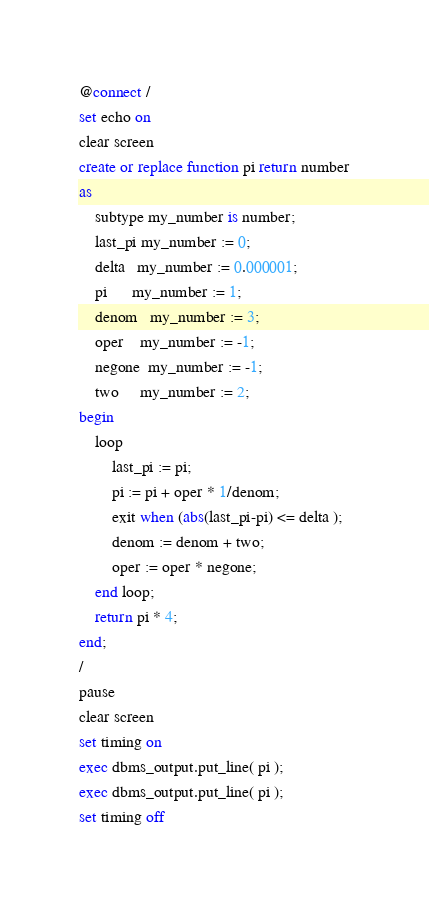Convert code to text. <code><loc_0><loc_0><loc_500><loc_500><_SQL_>@connect /
set echo on
clear screen
create or replace function pi return number
as
    subtype my_number is number;
    last_pi my_number := 0;
    delta   my_number := 0.000001;
    pi      my_number := 1;
    denom   my_number := 3;
    oper    my_number := -1;
    negone  my_number := -1;
    two     my_number := 2;
begin
    loop
        last_pi := pi;
        pi := pi + oper * 1/denom;
        exit when (abs(last_pi-pi) <= delta );
        denom := denom + two;
        oper := oper * negone;
    end loop;
    return pi * 4;
end;
/
pause
clear screen
set timing on
exec dbms_output.put_line( pi );
exec dbms_output.put_line( pi );
set timing off
</code> 